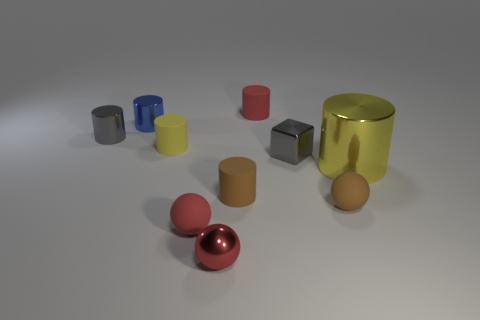What can you infer about the materials used for the different objects based on their appearances? The objects' appearances suggest a variety of materials. The shiny and reflective spheres and cylinders indicate metallic materials, possibly stainless steel or aluminum, given their luster. The duller, more opaque objects might be made of plastics or ceramics, inferred from their matte surfaces which don't reflect light the same way metals do. The different appearances are clues to the diversity in materials, each with its unique properties and aesthetics. 